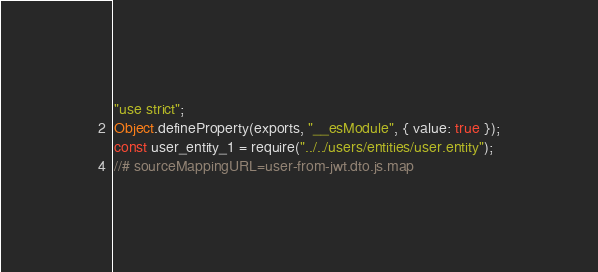<code> <loc_0><loc_0><loc_500><loc_500><_JavaScript_>"use strict";
Object.defineProperty(exports, "__esModule", { value: true });
const user_entity_1 = require("../../users/entities/user.entity");
//# sourceMappingURL=user-from-jwt.dto.js.map</code> 